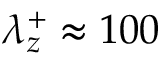<formula> <loc_0><loc_0><loc_500><loc_500>\lambda _ { z } ^ { + } \approx 1 0 0</formula> 